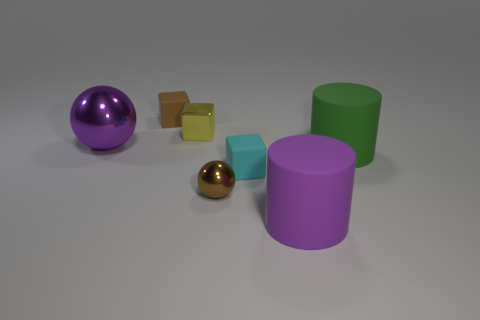How many other objects are the same shape as the big green rubber object?
Offer a very short reply. 1. What is the size of the cyan thing?
Provide a short and direct response. Small. What size is the metal object that is right of the large metallic thing and behind the large green matte cylinder?
Make the answer very short. Small. There is a brown object to the right of the yellow object; what shape is it?
Give a very brief answer. Sphere. Are the large green cylinder and the big purple thing that is in front of the purple ball made of the same material?
Ensure brevity in your answer.  Yes. Do the large purple shiny thing and the tiny cyan rubber thing have the same shape?
Offer a very short reply. No. There is a tiny cyan object that is the same shape as the yellow object; what material is it?
Your answer should be very brief. Rubber. The rubber object that is right of the cyan rubber cube and behind the tiny brown metal object is what color?
Offer a terse response. Green. What is the color of the metallic block?
Your answer should be very brief. Yellow. There is another thing that is the same color as the big metallic object; what is it made of?
Your answer should be very brief. Rubber. 